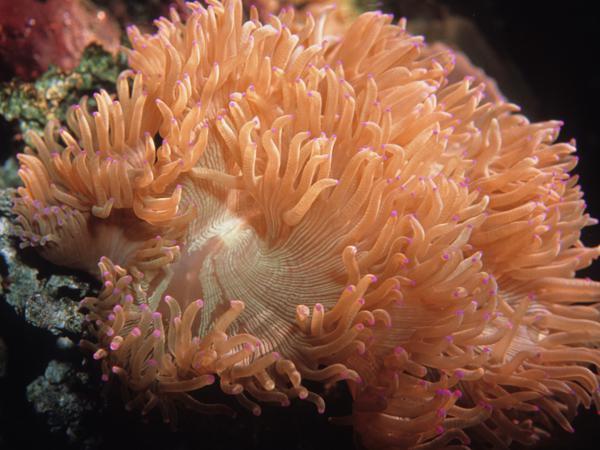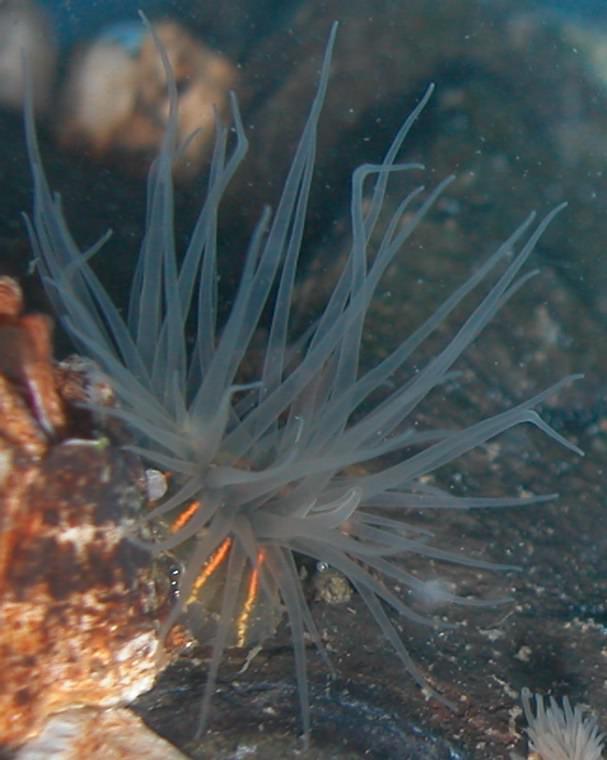The first image is the image on the left, the second image is the image on the right. Examine the images to the left and right. Is the description "The left image shows a side view of an anemone with an orange stalk and orange tendrils, and the right image shows a rounded orange anemone with no stalk." accurate? Answer yes or no. No. 